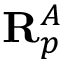<formula> <loc_0><loc_0><loc_500><loc_500>R _ { p } ^ { A }</formula> 